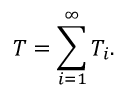<formula> <loc_0><loc_0><loc_500><loc_500>T = \sum _ { i = 1 } ^ { \infty } T _ { i } .</formula> 